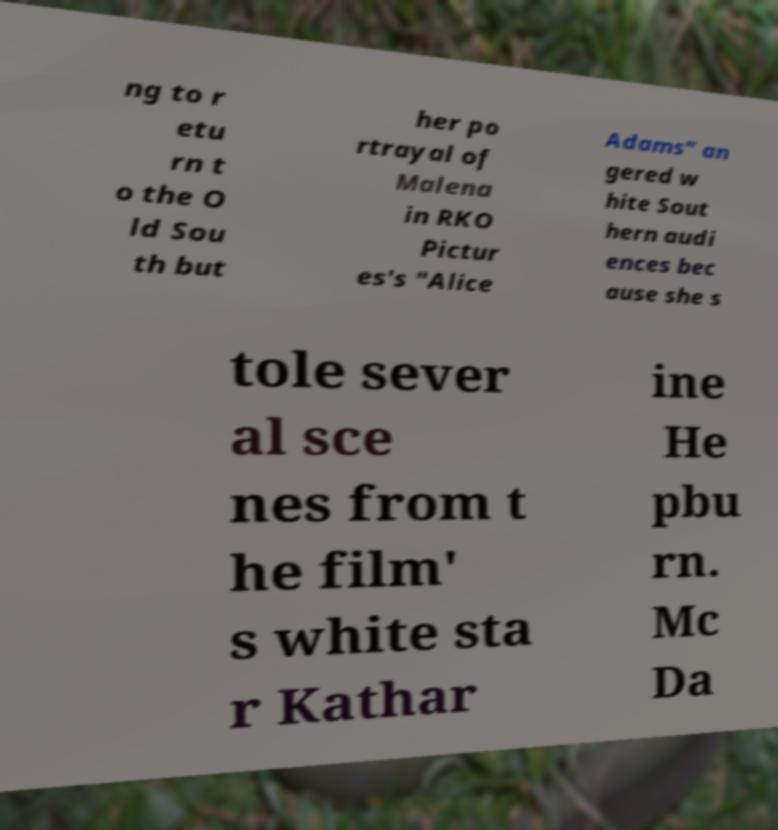Please identify and transcribe the text found in this image. ng to r etu rn t o the O ld Sou th but her po rtrayal of Malena in RKO Pictur es's "Alice Adams" an gered w hite Sout hern audi ences bec ause she s tole sever al sce nes from t he film' s white sta r Kathar ine He pbu rn. Mc Da 